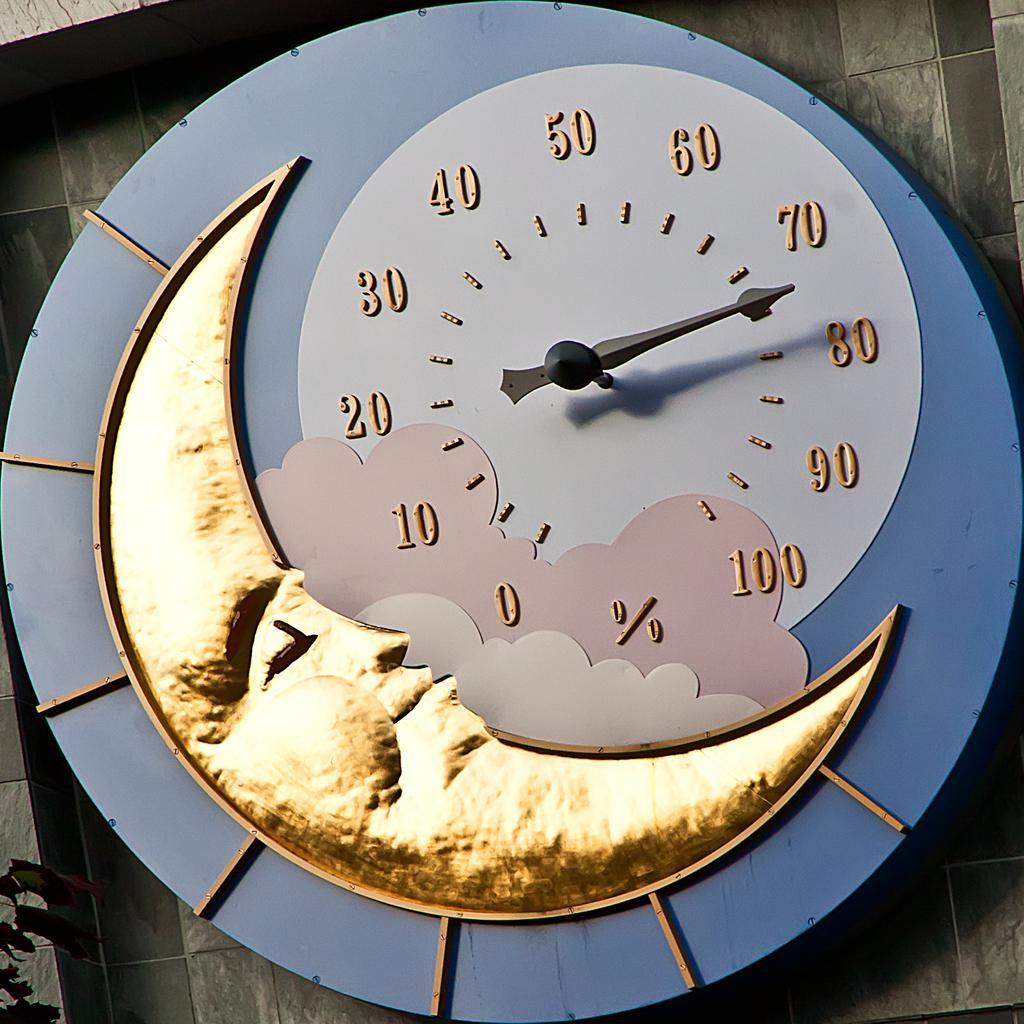Could you give a brief overview of what you see in this image? In the center of the image there is a wall. On the wall, we can see one wall clock. On the wall clock, we can see one half moon design, in which we can see one human face. At the bottom left side of the image, we can see leaves. 